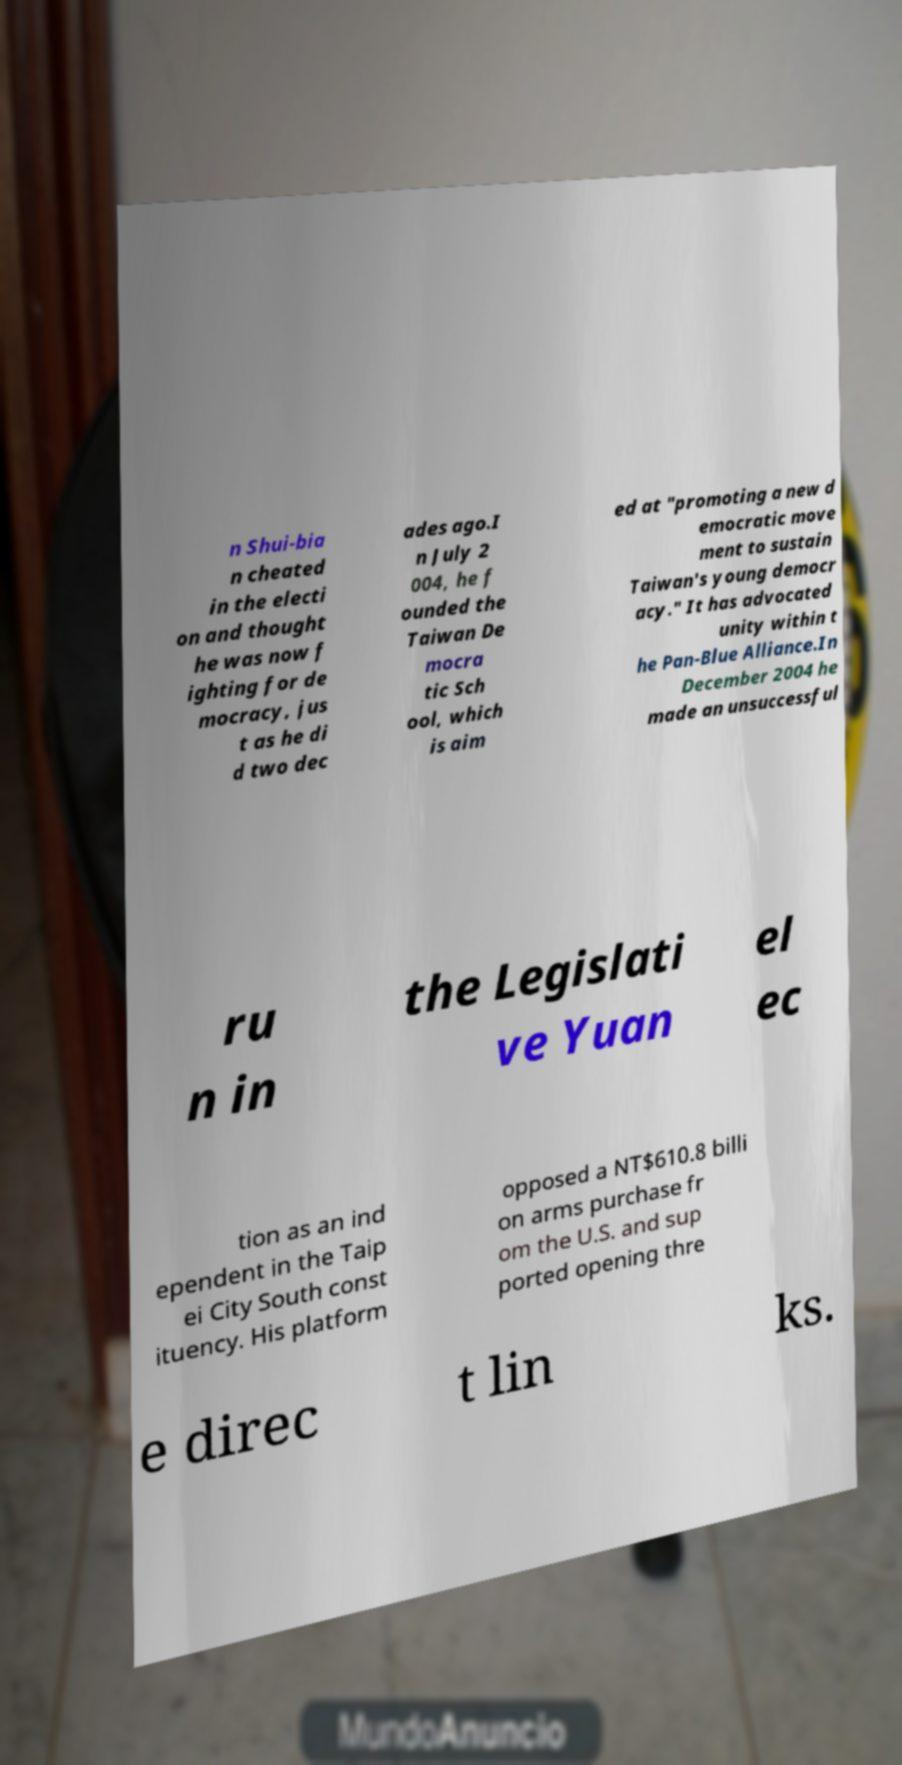Can you read and provide the text displayed in the image?This photo seems to have some interesting text. Can you extract and type it out for me? n Shui-bia n cheated in the electi on and thought he was now f ighting for de mocracy, jus t as he di d two dec ades ago.I n July 2 004, he f ounded the Taiwan De mocra tic Sch ool, which is aim ed at "promoting a new d emocratic move ment to sustain Taiwan's young democr acy." It has advocated unity within t he Pan-Blue Alliance.In December 2004 he made an unsuccessful ru n in the Legislati ve Yuan el ec tion as an ind ependent in the Taip ei City South const ituency. His platform opposed a NT$610.8 billi on arms purchase fr om the U.S. and sup ported opening thre e direc t lin ks. 